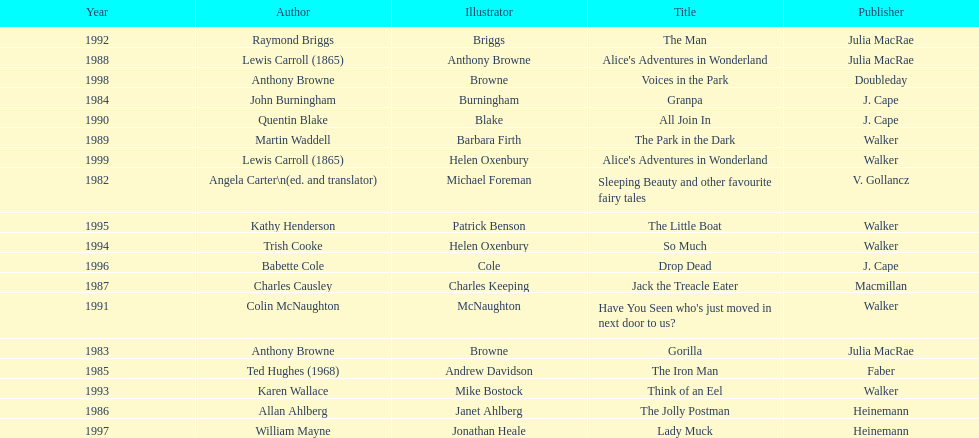How many titles did walker publish? 6. 